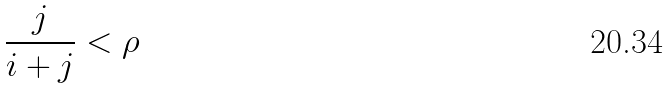<formula> <loc_0><loc_0><loc_500><loc_500>\frac { j } { i + j } < \rho</formula> 